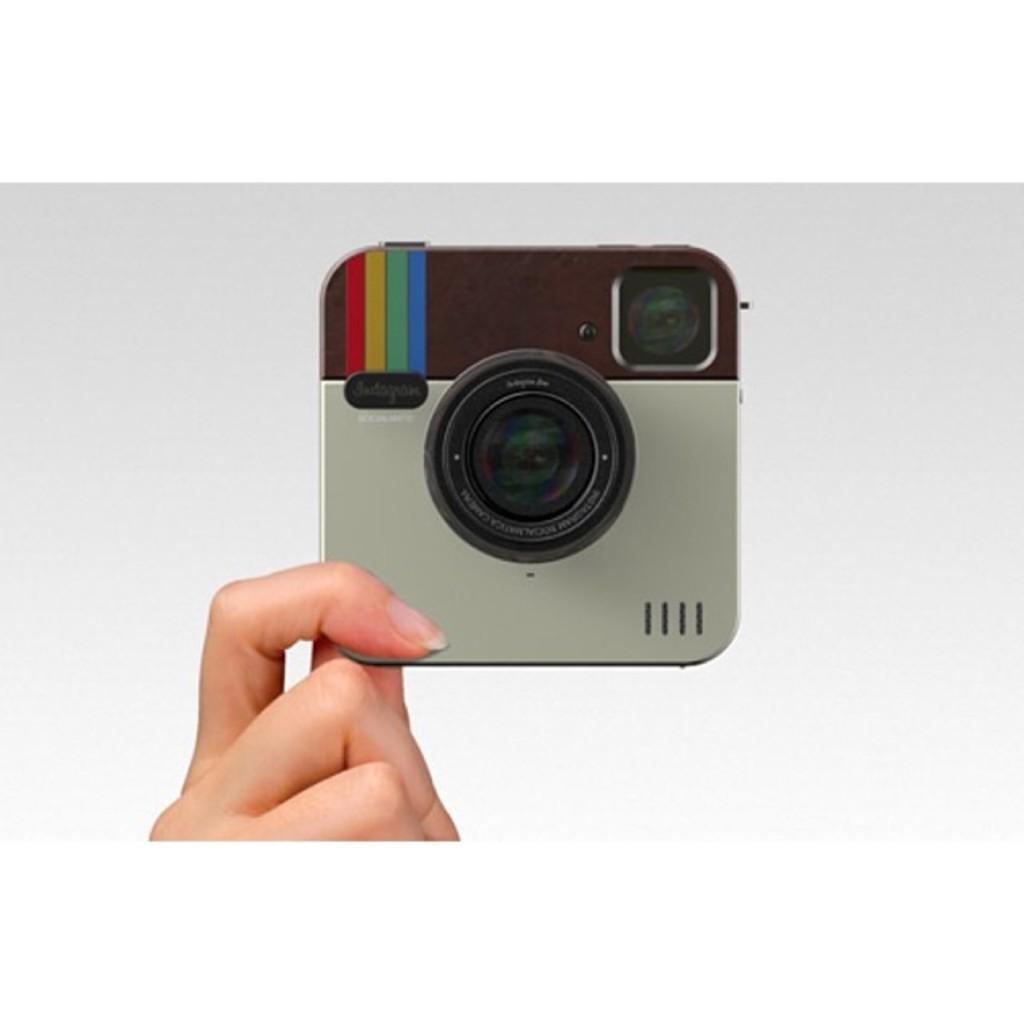Describe this image in one or two sentences. In this image I can see a person's hand holding an object. This object seems to be a camera. The background is in white color. 